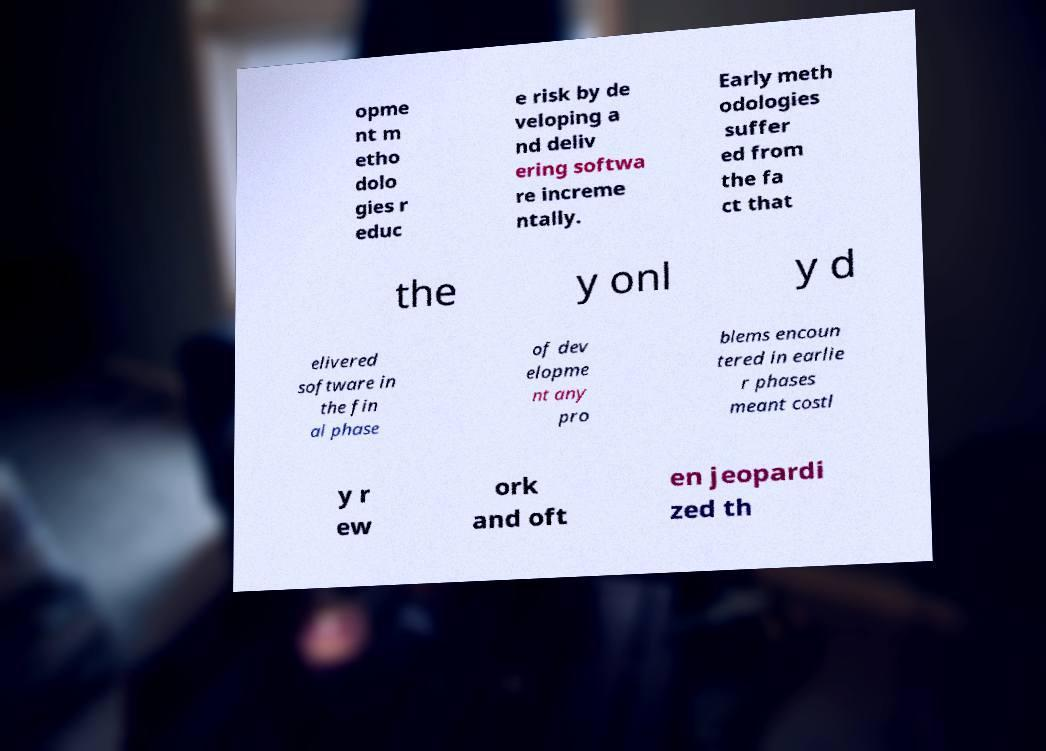Can you read and provide the text displayed in the image?This photo seems to have some interesting text. Can you extract and type it out for me? opme nt m etho dolo gies r educ e risk by de veloping a nd deliv ering softwa re increme ntally. Early meth odologies suffer ed from the fa ct that the y onl y d elivered software in the fin al phase of dev elopme nt any pro blems encoun tered in earlie r phases meant costl y r ew ork and oft en jeopardi zed th 